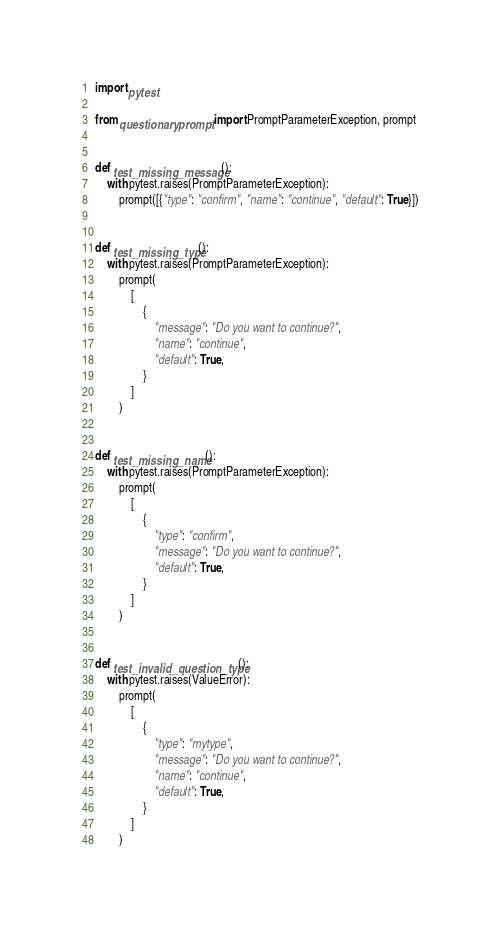<code> <loc_0><loc_0><loc_500><loc_500><_Python_>import pytest

from questionary.prompt import PromptParameterException, prompt


def test_missing_message():
    with pytest.raises(PromptParameterException):
        prompt([{"type": "confirm", "name": "continue", "default": True}])


def test_missing_type():
    with pytest.raises(PromptParameterException):
        prompt(
            [
                {
                    "message": "Do you want to continue?",
                    "name": "continue",
                    "default": True,
                }
            ]
        )


def test_missing_name():
    with pytest.raises(PromptParameterException):
        prompt(
            [
                {
                    "type": "confirm",
                    "message": "Do you want to continue?",
                    "default": True,
                }
            ]
        )


def test_invalid_question_type():
    with pytest.raises(ValueError):
        prompt(
            [
                {
                    "type": "mytype",
                    "message": "Do you want to continue?",
                    "name": "continue",
                    "default": True,
                }
            ]
        )
</code> 